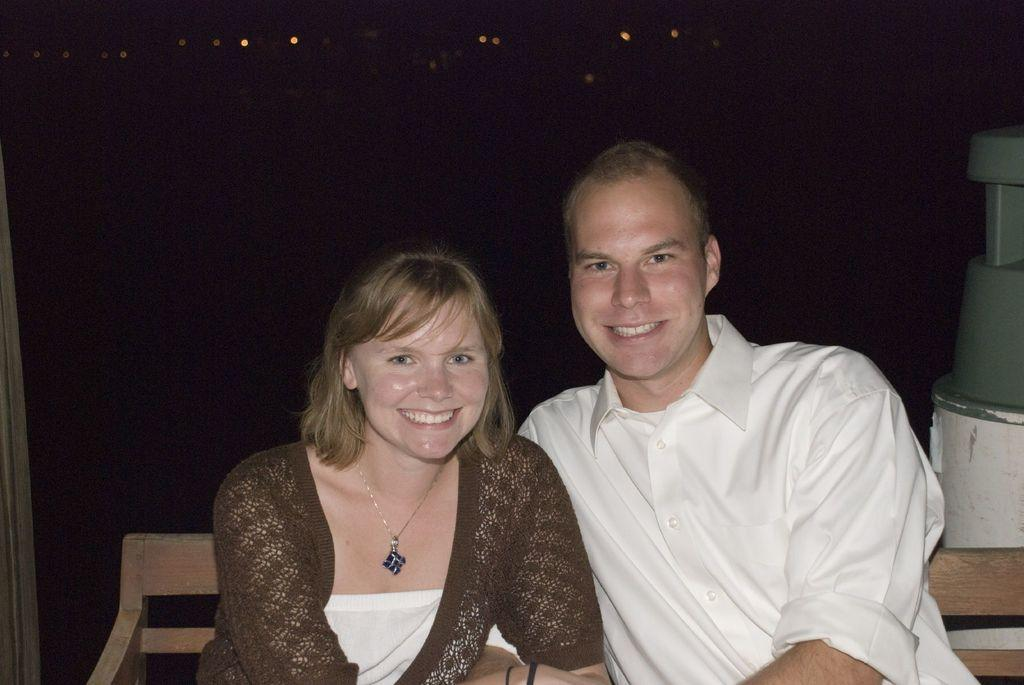Who is present in the image? There is a couple in the image. What are they doing in the image? The couple is sitting in a wooden chair. What can be seen in the right corner of the image? There is an object in the right corner of the image. What is visible in the background of the image? There are lights visible in the background of the image. How many bears can be seen in the image? There are no bears present in the image. Is the couple in the image walking in space? The image does not depict the couple in space; they are sitting in a wooden chair. 